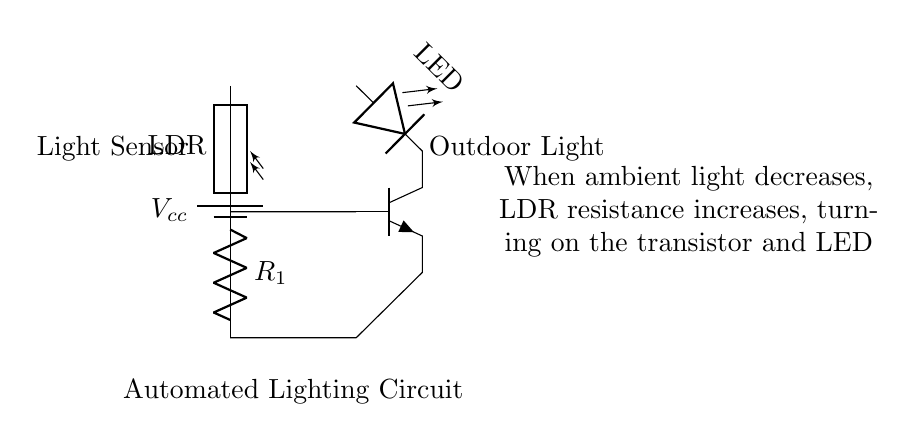What is the type of light sensor used in this circuit? The circuit diagram features a light-dependent resistor (LDR), which changes its resistance based on ambient light. Its presence is indicated in the schema.
Answer: LDR What happens to the LED when it gets dark? When ambient light decreases, the resistance of the LDR increases, which leads to the transistor being activated, allowing current to flow and the LED to illuminate.
Answer: It turns on How is the transistor connected in this circuit? The base of the transistor is connected to the LDR, the collector to the LED, and the emitter to ground. This allows the LDR to control the transistor's switching function.
Answer: In series with the LED What is the purpose of the resistor R1 in the circuit? Resistor R1 helps to limit the current flowing through the LDR and the transistor, preventing damage and ensuring proper operation of the circuit.
Answer: Current limiting What initiates the activation of the outdoor light? The outdoor light gets activated when the LDR detects low light levels, increasing its resistance, which triggers the transistor to conduct.
Answer: Low light levels What is the voltage supply denoted as in the circuit? The voltage supply in the diagram is labeled as Vcc, representing the power supply voltage needed for the circuit to function.
Answer: Vcc 